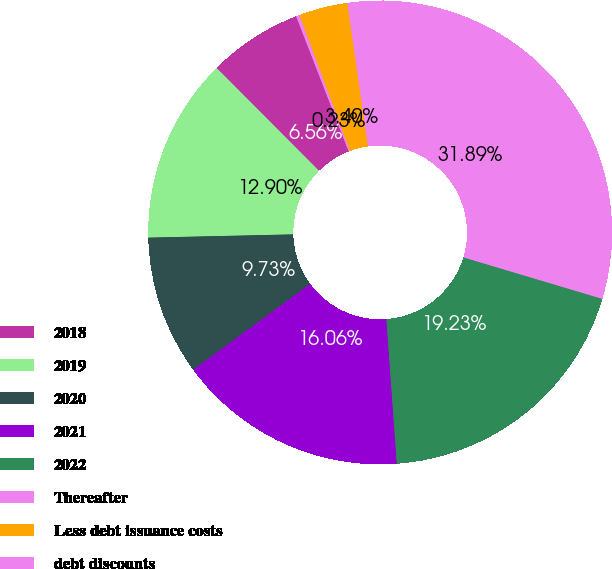<chart> <loc_0><loc_0><loc_500><loc_500><pie_chart><fcel>2018<fcel>2019<fcel>2020<fcel>2021<fcel>2022<fcel>Thereafter<fcel>Less debt issuance costs<fcel>debt discounts<nl><fcel>6.56%<fcel>12.9%<fcel>9.73%<fcel>16.06%<fcel>19.23%<fcel>31.89%<fcel>3.4%<fcel>0.23%<nl></chart> 